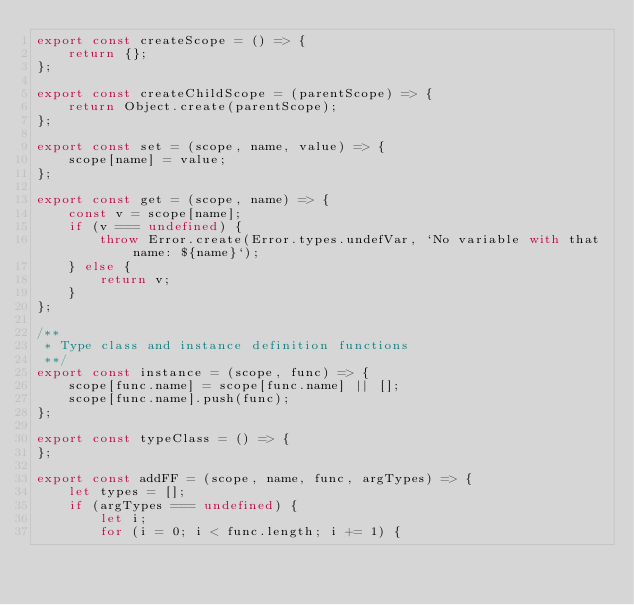<code> <loc_0><loc_0><loc_500><loc_500><_JavaScript_>export const createScope = () => {
    return {};
};

export const createChildScope = (parentScope) => {
    return Object.create(parentScope);
};

export const set = (scope, name, value) => {
    scope[name] = value;
};

export const get = (scope, name) => {
    const v = scope[name];
    if (v === undefined) {
        throw Error.create(Error.types.undefVar, `No variable with that name: ${name}`);
    } else {
        return v;
    }
};

/**
 * Type class and instance definition functions
 **/
export const instance = (scope, func) => {
    scope[func.name] = scope[func.name] || [];
    scope[func.name].push(func);
};

export const typeClass = () => {
};

export const addFF = (scope, name, func, argTypes) => {
    let types = [];
    if (argTypes === undefined) {
        let i;
        for (i = 0; i < func.length; i += 1) {</code> 